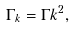Convert formula to latex. <formula><loc_0><loc_0><loc_500><loc_500>\Gamma _ { k } = \Gamma k ^ { 2 } ,</formula> 